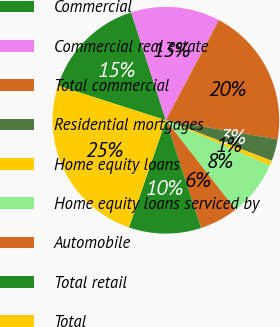Convert chart. <chart><loc_0><loc_0><loc_500><loc_500><pie_chart><fcel>Commercial<fcel>Commercial real estate<fcel>Total commercial<fcel>Residential mortgages<fcel>Home equity loans<fcel>Home equity loans serviced by<fcel>Automobile<fcel>Total retail<fcel>Total<nl><fcel>15.09%<fcel>12.7%<fcel>19.96%<fcel>3.12%<fcel>0.73%<fcel>7.91%<fcel>5.52%<fcel>10.3%<fcel>24.67%<nl></chart> 